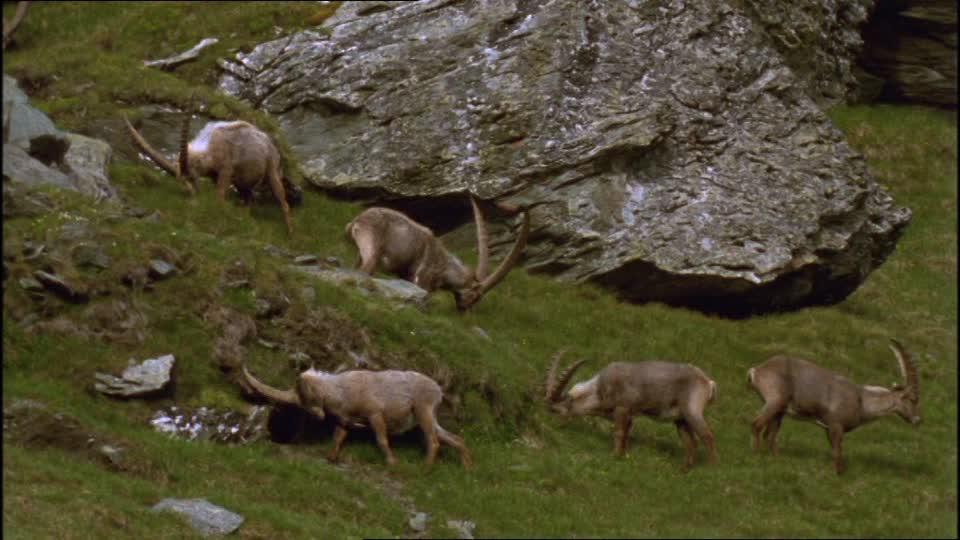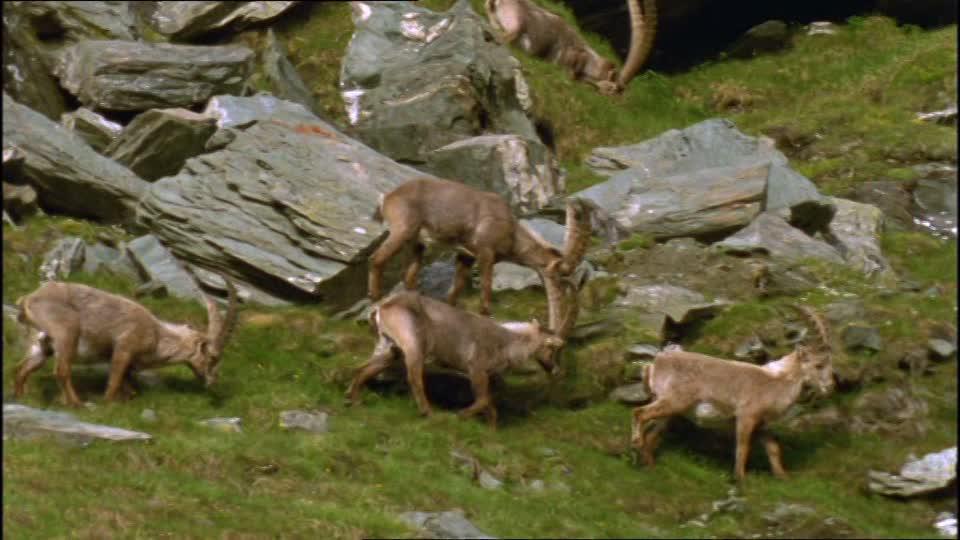The first image is the image on the left, the second image is the image on the right. For the images shown, is this caption "An image shows multiple horned animals standing atop a rocky peak." true? Answer yes or no. No. The first image is the image on the left, the second image is the image on the right. Assess this claim about the two images: "At least one of the animals is standing on a boulder in one of the images.". Correct or not? Answer yes or no. No. 